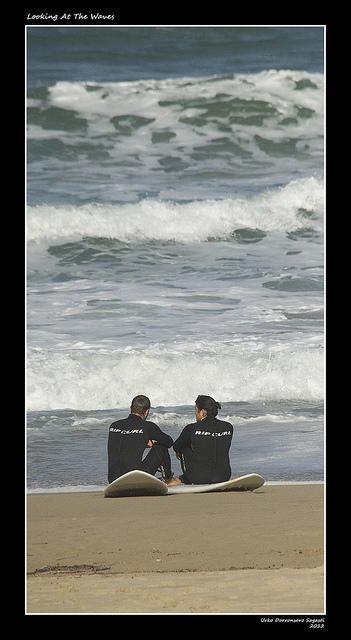How many men are there?
Give a very brief answer. 2. How many white caps are in the ocean?
Give a very brief answer. 3. How many people are there?
Give a very brief answer. 2. 